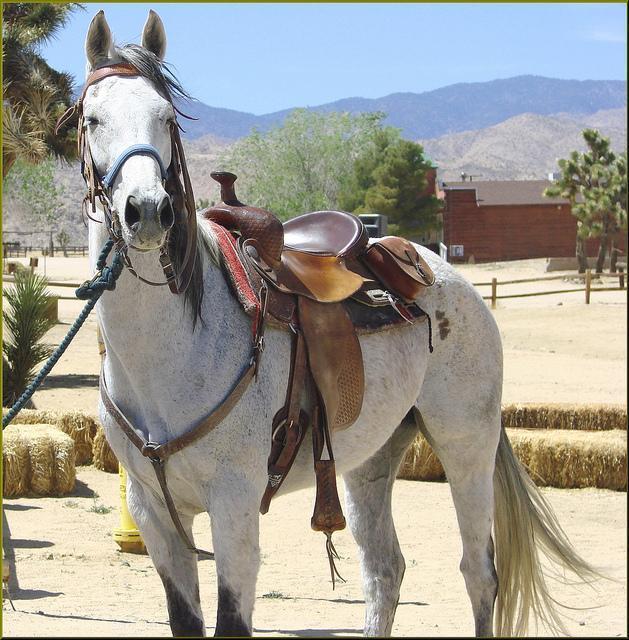How many horses can you see?
Give a very brief answer. 1. 